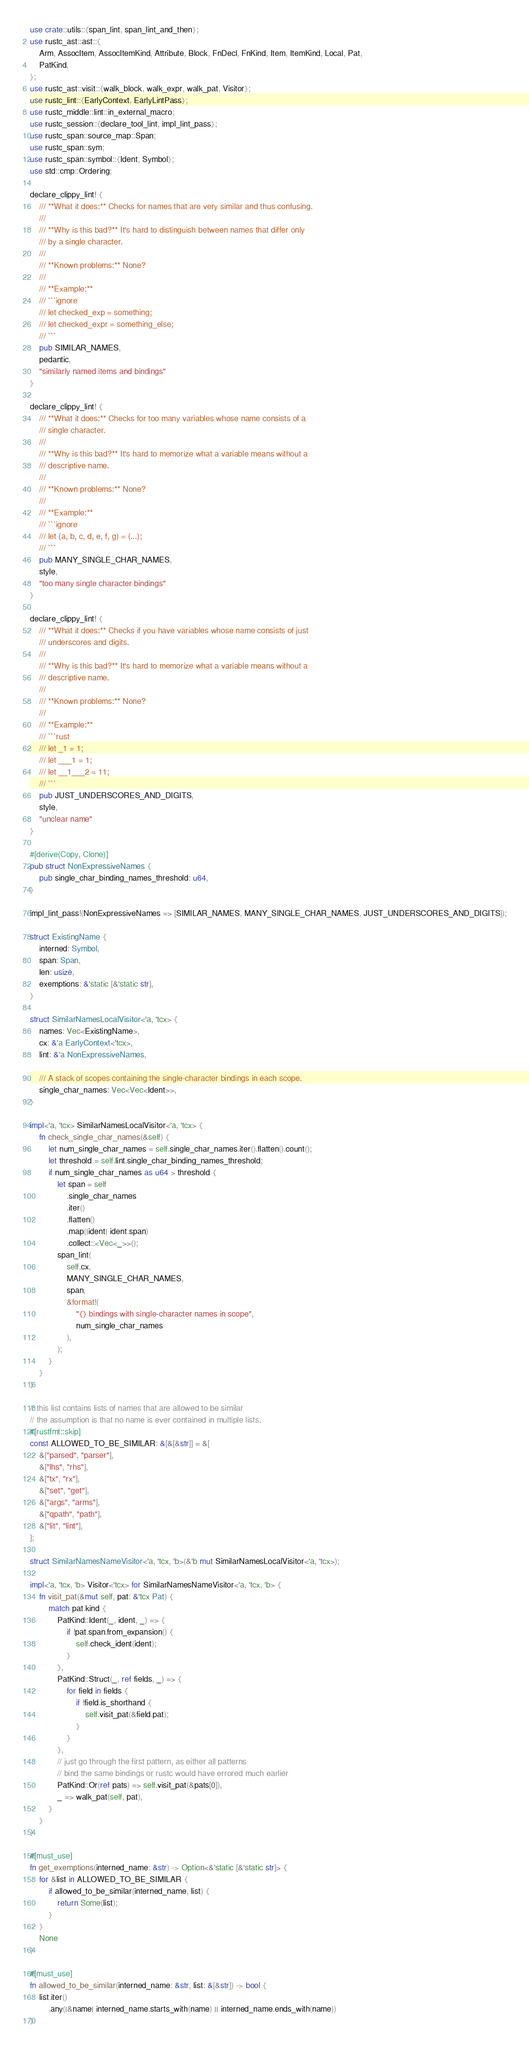Convert code to text. <code><loc_0><loc_0><loc_500><loc_500><_Rust_>use crate::utils::{span_lint, span_lint_and_then};
use rustc_ast::ast::{
    Arm, AssocItem, AssocItemKind, Attribute, Block, FnDecl, FnKind, Item, ItemKind, Local, Pat,
    PatKind,
};
use rustc_ast::visit::{walk_block, walk_expr, walk_pat, Visitor};
use rustc_lint::{EarlyContext, EarlyLintPass};
use rustc_middle::lint::in_external_macro;
use rustc_session::{declare_tool_lint, impl_lint_pass};
use rustc_span::source_map::Span;
use rustc_span::sym;
use rustc_span::symbol::{Ident, Symbol};
use std::cmp::Ordering;

declare_clippy_lint! {
    /// **What it does:** Checks for names that are very similar and thus confusing.
    ///
    /// **Why is this bad?** It's hard to distinguish between names that differ only
    /// by a single character.
    ///
    /// **Known problems:** None?
    ///
    /// **Example:**
    /// ```ignore
    /// let checked_exp = something;
    /// let checked_expr = something_else;
    /// ```
    pub SIMILAR_NAMES,
    pedantic,
    "similarly named items and bindings"
}

declare_clippy_lint! {
    /// **What it does:** Checks for too many variables whose name consists of a
    /// single character.
    ///
    /// **Why is this bad?** It's hard to memorize what a variable means without a
    /// descriptive name.
    ///
    /// **Known problems:** None?
    ///
    /// **Example:**
    /// ```ignore
    /// let (a, b, c, d, e, f, g) = (...);
    /// ```
    pub MANY_SINGLE_CHAR_NAMES,
    style,
    "too many single character bindings"
}

declare_clippy_lint! {
    /// **What it does:** Checks if you have variables whose name consists of just
    /// underscores and digits.
    ///
    /// **Why is this bad?** It's hard to memorize what a variable means without a
    /// descriptive name.
    ///
    /// **Known problems:** None?
    ///
    /// **Example:**
    /// ```rust
    /// let _1 = 1;
    /// let ___1 = 1;
    /// let __1___2 = 11;
    /// ```
    pub JUST_UNDERSCORES_AND_DIGITS,
    style,
    "unclear name"
}

#[derive(Copy, Clone)]
pub struct NonExpressiveNames {
    pub single_char_binding_names_threshold: u64,
}

impl_lint_pass!(NonExpressiveNames => [SIMILAR_NAMES, MANY_SINGLE_CHAR_NAMES, JUST_UNDERSCORES_AND_DIGITS]);

struct ExistingName {
    interned: Symbol,
    span: Span,
    len: usize,
    exemptions: &'static [&'static str],
}

struct SimilarNamesLocalVisitor<'a, 'tcx> {
    names: Vec<ExistingName>,
    cx: &'a EarlyContext<'tcx>,
    lint: &'a NonExpressiveNames,

    /// A stack of scopes containing the single-character bindings in each scope.
    single_char_names: Vec<Vec<Ident>>,
}

impl<'a, 'tcx> SimilarNamesLocalVisitor<'a, 'tcx> {
    fn check_single_char_names(&self) {
        let num_single_char_names = self.single_char_names.iter().flatten().count();
        let threshold = self.lint.single_char_binding_names_threshold;
        if num_single_char_names as u64 > threshold {
            let span = self
                .single_char_names
                .iter()
                .flatten()
                .map(|ident| ident.span)
                .collect::<Vec<_>>();
            span_lint(
                self.cx,
                MANY_SINGLE_CHAR_NAMES,
                span,
                &format!(
                    "{} bindings with single-character names in scope",
                    num_single_char_names
                ),
            );
        }
    }
}

// this list contains lists of names that are allowed to be similar
// the assumption is that no name is ever contained in multiple lists.
#[rustfmt::skip]
const ALLOWED_TO_BE_SIMILAR: &[&[&str]] = &[
    &["parsed", "parser"],
    &["lhs", "rhs"],
    &["tx", "rx"],
    &["set", "get"],
    &["args", "arms"],
    &["qpath", "path"],
    &["lit", "lint"],
];

struct SimilarNamesNameVisitor<'a, 'tcx, 'b>(&'b mut SimilarNamesLocalVisitor<'a, 'tcx>);

impl<'a, 'tcx, 'b> Visitor<'tcx> for SimilarNamesNameVisitor<'a, 'tcx, 'b> {
    fn visit_pat(&mut self, pat: &'tcx Pat) {
        match pat.kind {
            PatKind::Ident(_, ident, _) => {
                if !pat.span.from_expansion() {
                    self.check_ident(ident);
                }
            },
            PatKind::Struct(_, ref fields, _) => {
                for field in fields {
                    if !field.is_shorthand {
                        self.visit_pat(&field.pat);
                    }
                }
            },
            // just go through the first pattern, as either all patterns
            // bind the same bindings or rustc would have errored much earlier
            PatKind::Or(ref pats) => self.visit_pat(&pats[0]),
            _ => walk_pat(self, pat),
        }
    }
}

#[must_use]
fn get_exemptions(interned_name: &str) -> Option<&'static [&'static str]> {
    for &list in ALLOWED_TO_BE_SIMILAR {
        if allowed_to_be_similar(interned_name, list) {
            return Some(list);
        }
    }
    None
}

#[must_use]
fn allowed_to_be_similar(interned_name: &str, list: &[&str]) -> bool {
    list.iter()
        .any(|&name| interned_name.starts_with(name) || interned_name.ends_with(name))
}
</code> 